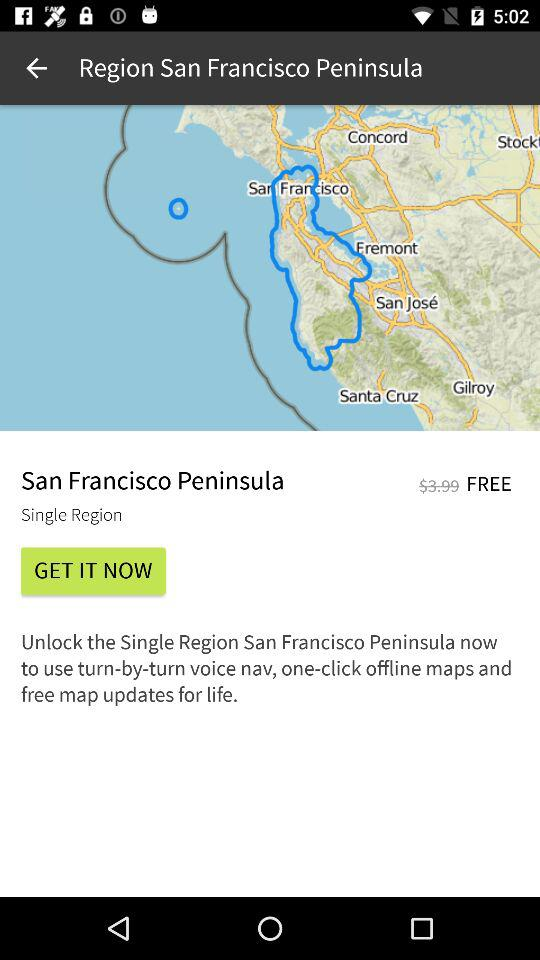When was the application copyrighted?
When the provided information is insufficient, respond with <no answer>. <no answer> 